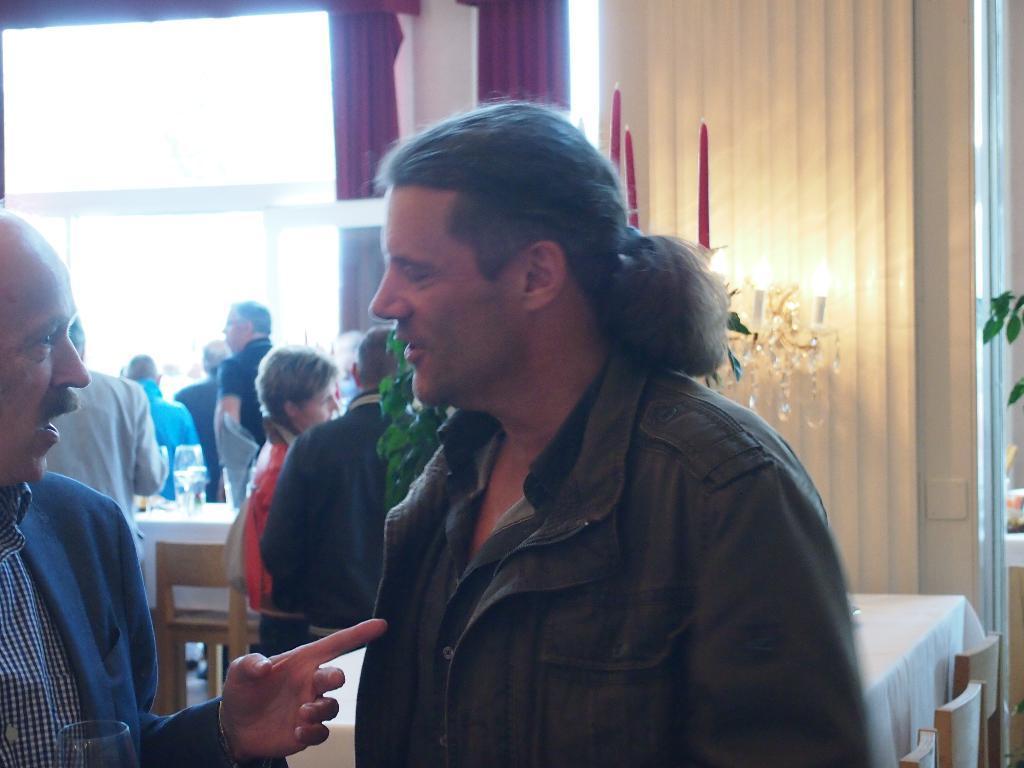In one or two sentences, can you explain what this image depicts? As we can see in the image, there is a window, wall, curtain, candle, lights and few people standing over here and there are tables. On table there is a glass. 